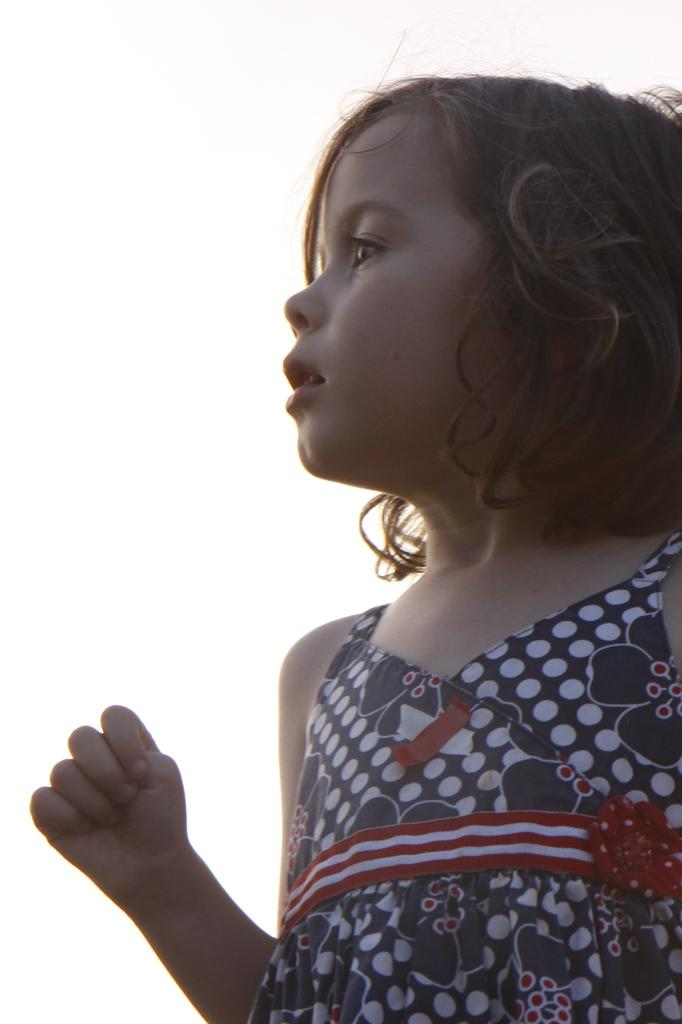What is present in the image? There is a person in the image. What is the person wearing? The person is wearing a frock. What type of wine is the person holding in the image? There is no wine present in the image; the person is wearing a frock. How many matches are visible in the image? There are no matches present in the image; the person is wearing a frock. 